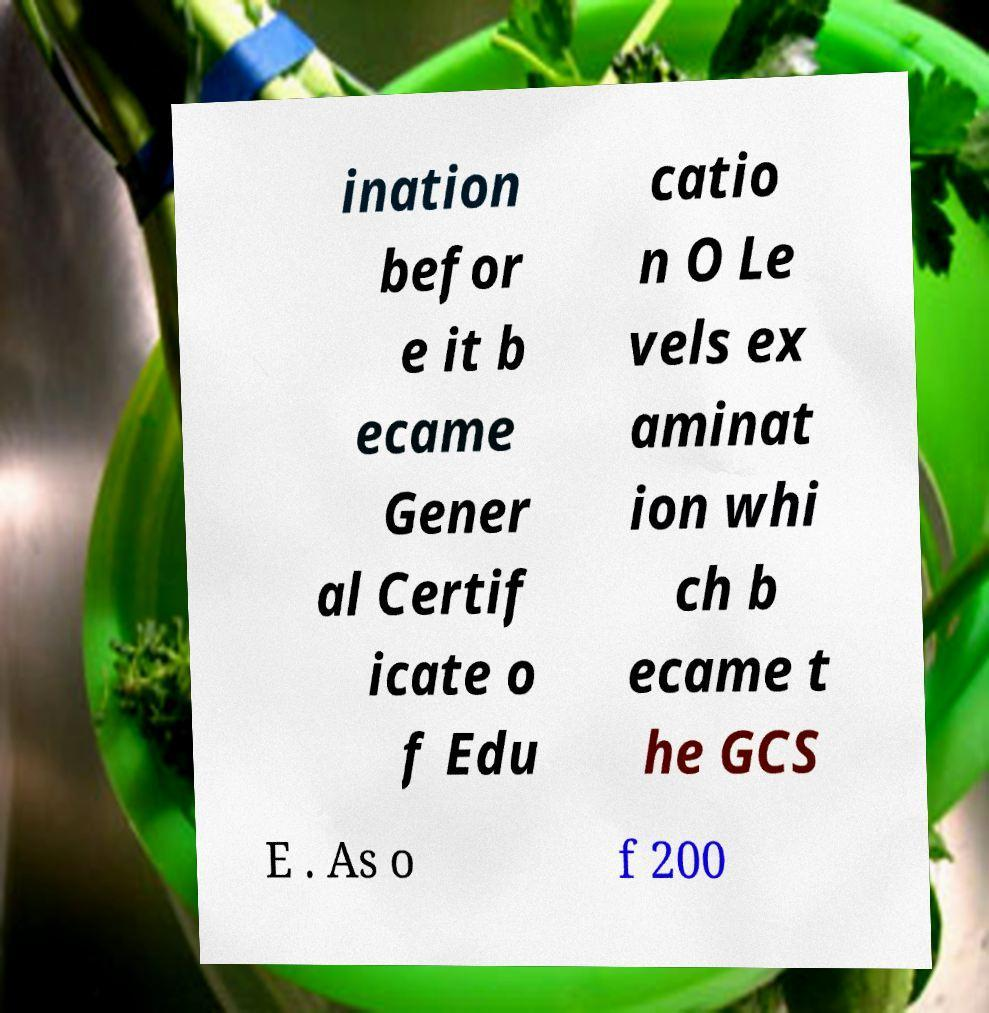Please read and relay the text visible in this image. What does it say? ination befor e it b ecame Gener al Certif icate o f Edu catio n O Le vels ex aminat ion whi ch b ecame t he GCS E . As o f 200 